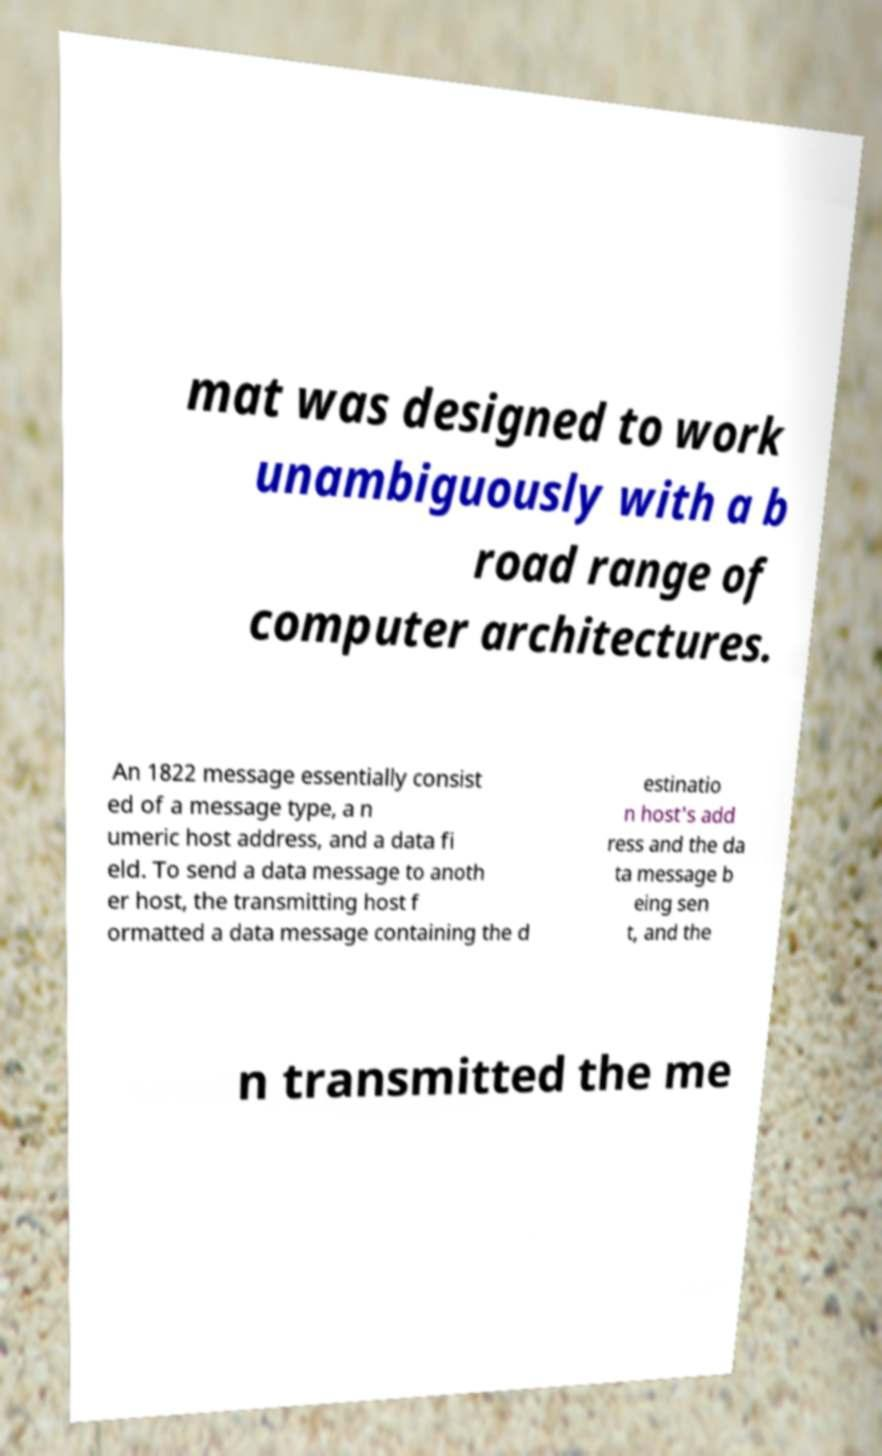Please read and relay the text visible in this image. What does it say? mat was designed to work unambiguously with a b road range of computer architectures. An 1822 message essentially consist ed of a message type, a n umeric host address, and a data fi eld. To send a data message to anoth er host, the transmitting host f ormatted a data message containing the d estinatio n host's add ress and the da ta message b eing sen t, and the n transmitted the me 